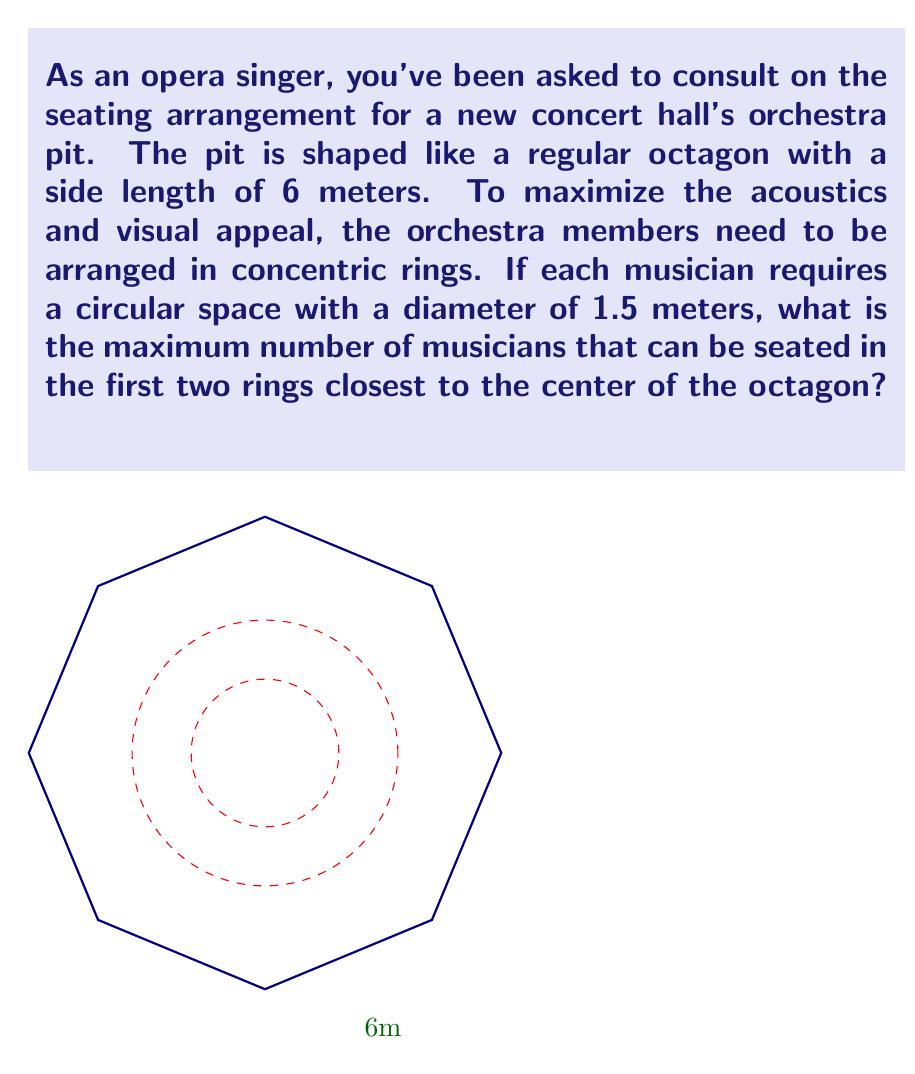What is the answer to this math problem? Let's approach this step-by-step:

1) First, we need to calculate the radius of the octagon:
   $$R = \frac{s}{2\tan(\frac{\pi}{8})} = \frac{6}{2\tan(\frac{\pi}{8})} \approx 7.82 \text{ meters}$$

2) The radius of space each musician occupies is:
   $$r = \frac{1.5}{2} = 0.75 \text{ meters}$$

3) For the first ring:
   - Its radius will be: $0.75 \text{ meters}$
   - Its circumference: $2\pi(0.75) \approx 4.71 \text{ meters}$
   - Number of musicians: $\lfloor\frac{4.71}{1.5}\rfloor = 3$

4) For the second ring:
   - Its radius will be: $0.75 + 1.5 = 2.25 \text{ meters}$
   - Its circumference: $2\pi(2.25) \approx 14.14 \text{ meters}$
   - Number of musicians: $\lfloor\frac{14.14}{1.5}\rfloor = 9$

5) Total number of musicians in the first two rings:
   $3 + 9 = 12$

Therefore, the maximum number of musicians that can be seated in the first two rings is 12.
Answer: 12 musicians 